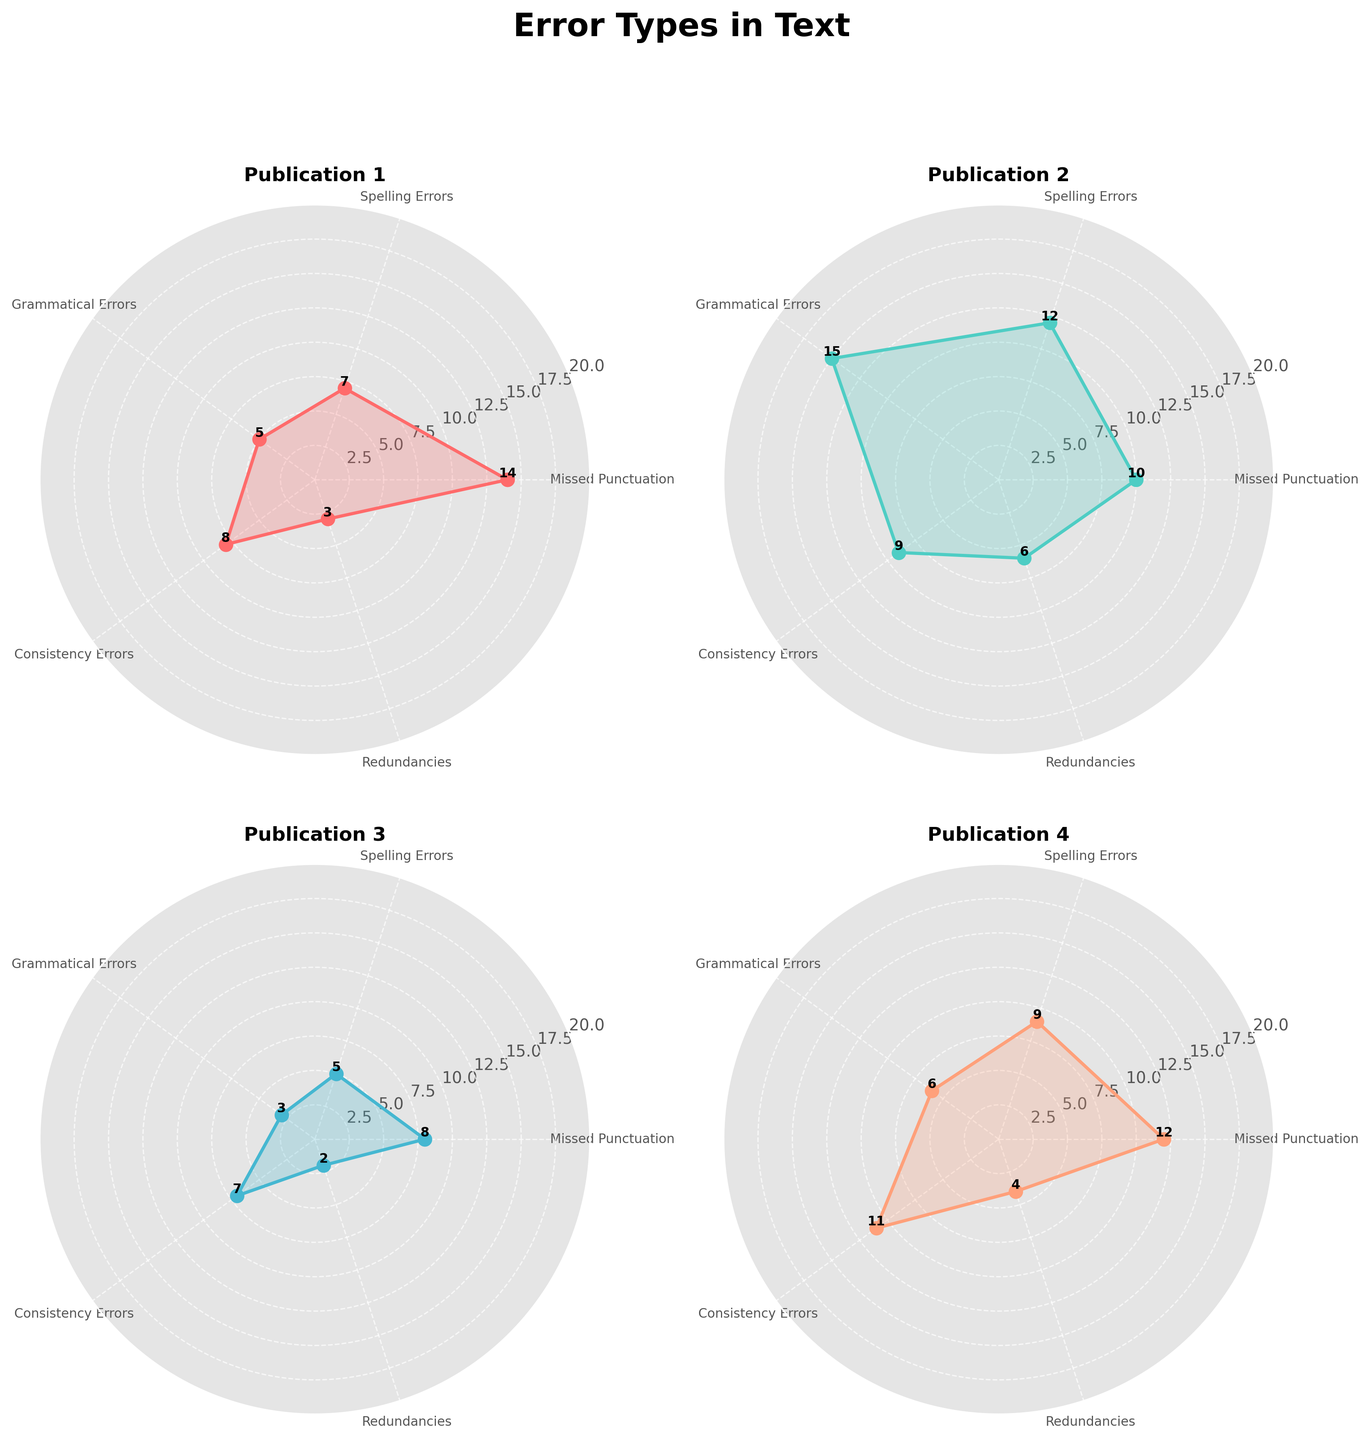What is the total number of missed punctuation errors across all publications? Sum the missed punctuation errors for each publication: 14 (Publication 1) + 10 (Publication 2) + 8 (Publication 3) + 12 (Publication 4). The total is 14 + 10 + 8 + 12 = 44.
Answer: 44 Which publication has the highest number of grammatical errors? Compare the number of grammatical errors for each publication: 5 (Publication 1), 15 (Publication 2), 3 (Publication 3), and 6 (Publication 4). The highest is 15 in Publication 2.
Answer: Publication 2 What is the range of spelling errors among all the publications? Identify the minimum and maximum spelling errors: The minimum is 5 (Publication 3) and the maximum is 12 (Publication 2). The range is 12 - 5 = 7.
Answer: 7 Which error type is most common in Publication 3? Compare all error types within Publication 3: Missed Punctuation (8), Spelling Errors (5), Grammatical Errors (3), Consistency Errors (7), Redundancies (2). The most common is Missed Punctuation with 8 errors.
Answer: Missed Punctuation What is the average number of redundancies across all publications? Calculate the sum of redundancies: 3 (Publication 1) + 6 (Publication 2) + 2 (Publication 3) + 4 (Publication 4) = 15. Average is 15 / 4 = 3.75.
Answer: 3.75 Which publication has the least consistency errors? Compare consistency errors for each publication: 8 (Publication 1), 9 (Publication 2), 7 (Publication 3), 11 (Publication 4). The least is 7 in Publication 3.
Answer: Publication 3 What is the difference in spelling errors between Publication 1 and Publication 4? Compare spelling errors: Publication 1 has 7, Publication 4 has 9. The difference is 9 - 7 = 2.
Answer: 2 In Publication 1, are there more spelling errors or grammatical errors? Compare errors in Publication 1: Spelling Errors (7), Grammatical Errors (5). There are more spelling errors than grammatical errors.
Answer: Spelling Errors How many error types in Publication 2 have values greater than 10? Identify error types in Publication 2 with values above 10: Spelling Errors (12), Grammatical Errors (15). Two types meet the criteria.
Answer: 2 What is the sum of all consistency errors and redundancies across all publications? Calculate the sum of consistency errors and redundancies: Consistency Errors (8 + 9 + 7 + 11 = 35), Redundancies (3 + 6 + 2 + 4 = 15). Total sum: 35 + 15 = 50.
Answer: 50 